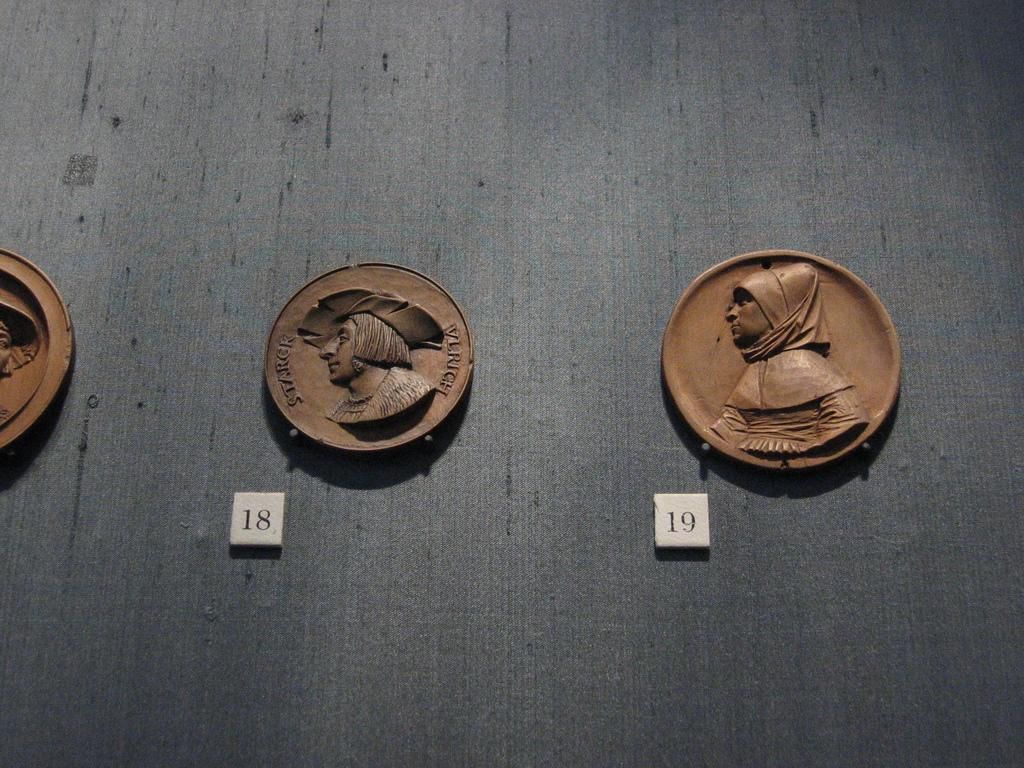<image>
Relay a brief, clear account of the picture shown. Two silhouette plaques hang on the wall and are labeled 18 and 19. 